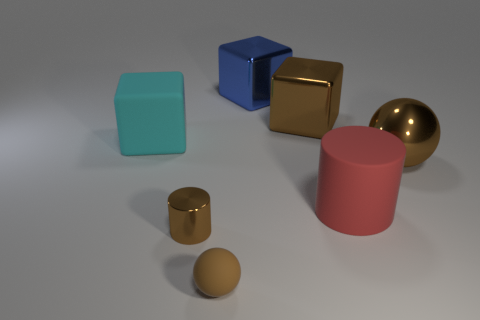Subtract all rubber cubes. How many cubes are left? 2 Add 1 big blue shiny blocks. How many objects exist? 8 Subtract all red cylinders. How many cylinders are left? 1 Subtract all cylinders. How many objects are left? 5 Subtract 2 cylinders. How many cylinders are left? 0 Add 7 brown cylinders. How many brown cylinders exist? 8 Subtract 0 purple balls. How many objects are left? 7 Subtract all yellow cylinders. Subtract all yellow blocks. How many cylinders are left? 2 Subtract all brown balls. Subtract all large brown metallic spheres. How many objects are left? 4 Add 3 cylinders. How many cylinders are left? 5 